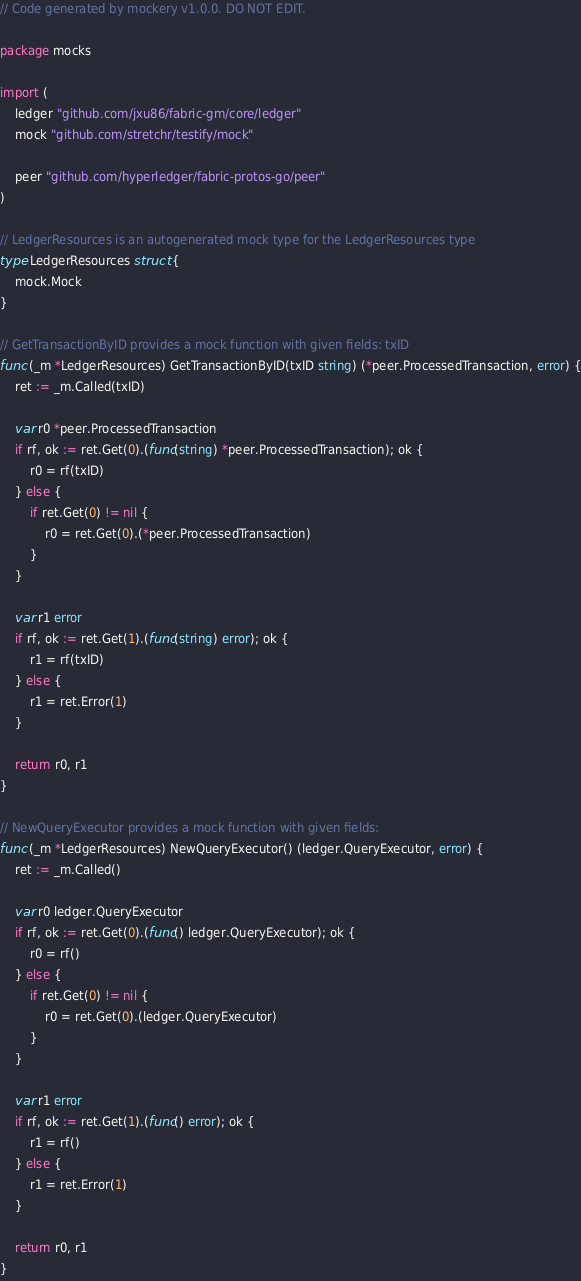Convert code to text. <code><loc_0><loc_0><loc_500><loc_500><_Go_>// Code generated by mockery v1.0.0. DO NOT EDIT.

package mocks

import (
	ledger "github.com/jxu86/fabric-gm/core/ledger"
	mock "github.com/stretchr/testify/mock"

	peer "github.com/hyperledger/fabric-protos-go/peer"
)

// LedgerResources is an autogenerated mock type for the LedgerResources type
type LedgerResources struct {
	mock.Mock
}

// GetTransactionByID provides a mock function with given fields: txID
func (_m *LedgerResources) GetTransactionByID(txID string) (*peer.ProcessedTransaction, error) {
	ret := _m.Called(txID)

	var r0 *peer.ProcessedTransaction
	if rf, ok := ret.Get(0).(func(string) *peer.ProcessedTransaction); ok {
		r0 = rf(txID)
	} else {
		if ret.Get(0) != nil {
			r0 = ret.Get(0).(*peer.ProcessedTransaction)
		}
	}

	var r1 error
	if rf, ok := ret.Get(1).(func(string) error); ok {
		r1 = rf(txID)
	} else {
		r1 = ret.Error(1)
	}

	return r0, r1
}

// NewQueryExecutor provides a mock function with given fields:
func (_m *LedgerResources) NewQueryExecutor() (ledger.QueryExecutor, error) {
	ret := _m.Called()

	var r0 ledger.QueryExecutor
	if rf, ok := ret.Get(0).(func() ledger.QueryExecutor); ok {
		r0 = rf()
	} else {
		if ret.Get(0) != nil {
			r0 = ret.Get(0).(ledger.QueryExecutor)
		}
	}

	var r1 error
	if rf, ok := ret.Get(1).(func() error); ok {
		r1 = rf()
	} else {
		r1 = ret.Error(1)
	}

	return r0, r1
}
</code> 